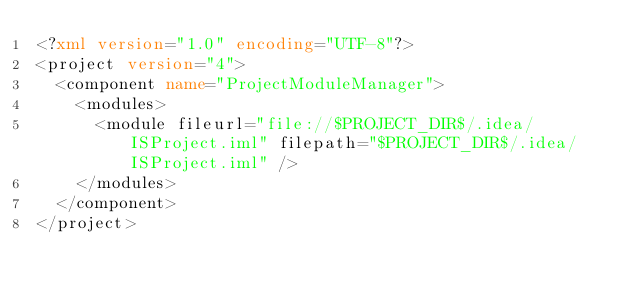Convert code to text. <code><loc_0><loc_0><loc_500><loc_500><_XML_><?xml version="1.0" encoding="UTF-8"?>
<project version="4">
  <component name="ProjectModuleManager">
    <modules>
      <module fileurl="file://$PROJECT_DIR$/.idea/ISProject.iml" filepath="$PROJECT_DIR$/.idea/ISProject.iml" />
    </modules>
  </component>
</project></code> 